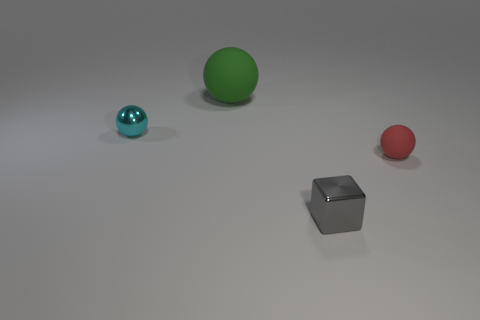Subtract all tiny metal spheres. How many spheres are left? 2 Subtract 1 spheres. How many spheres are left? 2 Add 2 tiny gray cylinders. How many objects exist? 6 Subtract all blocks. How many objects are left? 3 Subtract all gray balls. Subtract all green blocks. How many balls are left? 3 Add 3 large things. How many large things exist? 4 Subtract 0 purple cylinders. How many objects are left? 4 Subtract all cyan matte spheres. Subtract all small rubber objects. How many objects are left? 3 Add 2 tiny gray blocks. How many tiny gray blocks are left? 3 